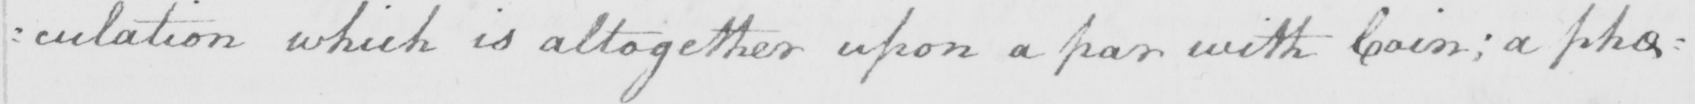Transcribe the text shown in this historical manuscript line. : culation which is altogether upon a par with Coin ; a phe= 